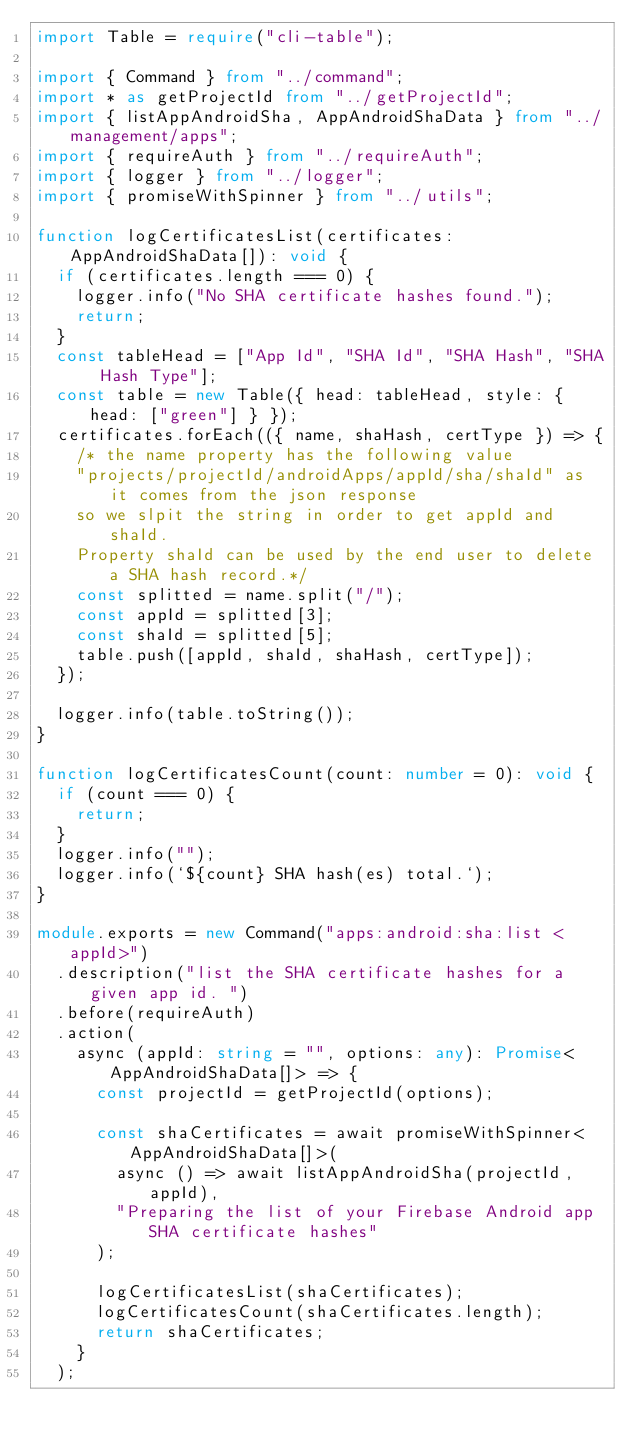Convert code to text. <code><loc_0><loc_0><loc_500><loc_500><_TypeScript_>import Table = require("cli-table");

import { Command } from "../command";
import * as getProjectId from "../getProjectId";
import { listAppAndroidSha, AppAndroidShaData } from "../management/apps";
import { requireAuth } from "../requireAuth";
import { logger } from "../logger";
import { promiseWithSpinner } from "../utils";

function logCertificatesList(certificates: AppAndroidShaData[]): void {
  if (certificates.length === 0) {
    logger.info("No SHA certificate hashes found.");
    return;
  }
  const tableHead = ["App Id", "SHA Id", "SHA Hash", "SHA Hash Type"];
  const table = new Table({ head: tableHead, style: { head: ["green"] } });
  certificates.forEach(({ name, shaHash, certType }) => {
    /* the name property has the following value 
    "projects/projectId/androidApps/appId/sha/shaId" as it comes from the json response
    so we slpit the string in order to get appId and shaId. 
    Property shaId can be used by the end user to delete a SHA hash record.*/
    const splitted = name.split("/");
    const appId = splitted[3];
    const shaId = splitted[5];
    table.push([appId, shaId, shaHash, certType]);
  });

  logger.info(table.toString());
}

function logCertificatesCount(count: number = 0): void {
  if (count === 0) {
    return;
  }
  logger.info("");
  logger.info(`${count} SHA hash(es) total.`);
}

module.exports = new Command("apps:android:sha:list <appId>")
  .description("list the SHA certificate hashes for a given app id. ")
  .before(requireAuth)
  .action(
    async (appId: string = "", options: any): Promise<AppAndroidShaData[]> => {
      const projectId = getProjectId(options);

      const shaCertificates = await promiseWithSpinner<AppAndroidShaData[]>(
        async () => await listAppAndroidSha(projectId, appId),
        "Preparing the list of your Firebase Android app SHA certificate hashes"
      );

      logCertificatesList(shaCertificates);
      logCertificatesCount(shaCertificates.length);
      return shaCertificates;
    }
  );
</code> 